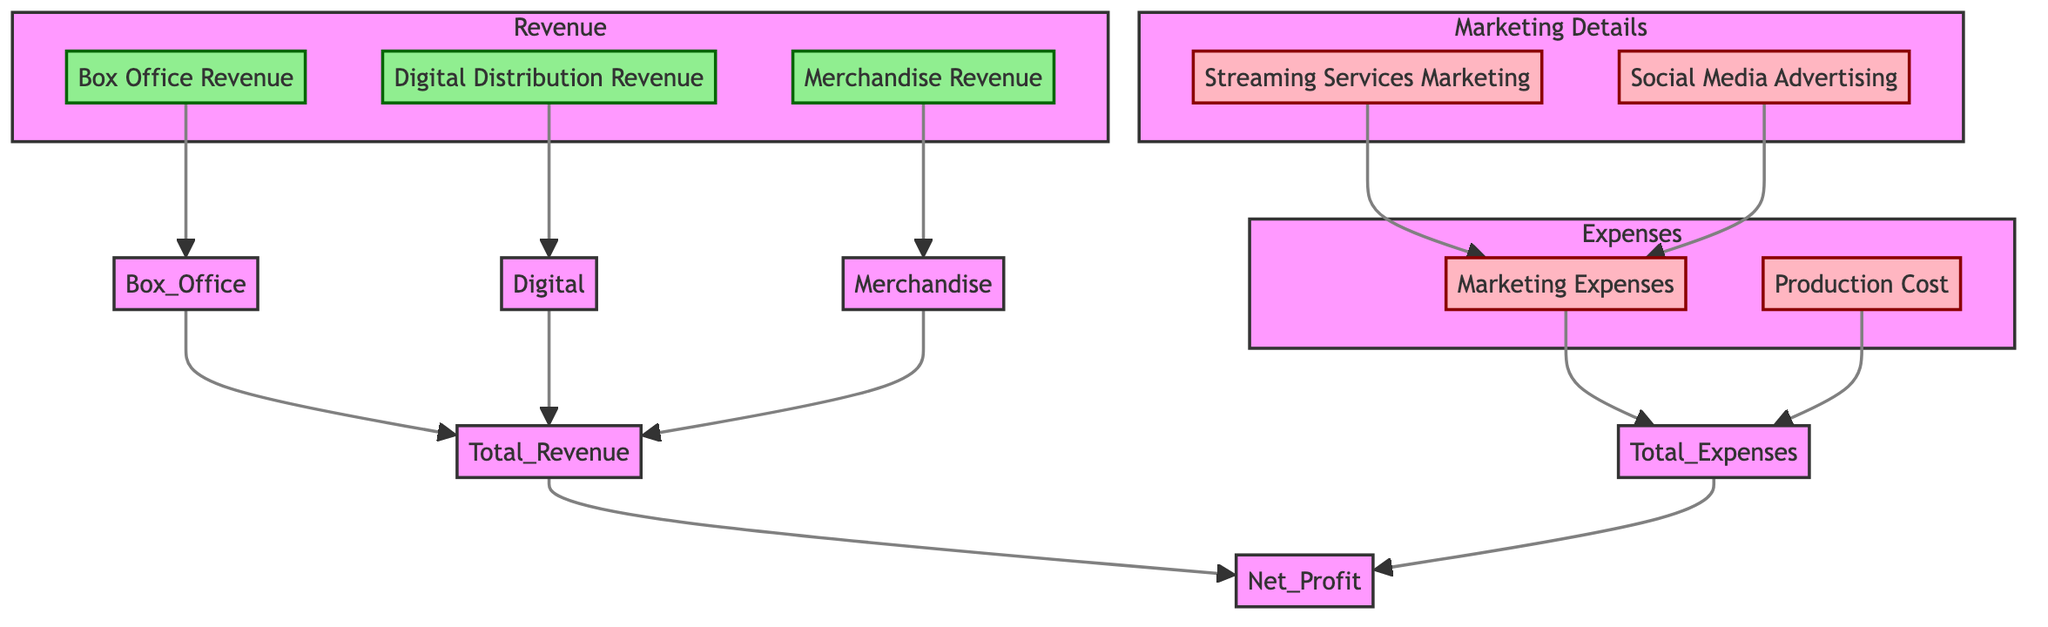What are the three sources of revenue in this diagram? The diagram clearly lists three specific revenue sources: Box Office Revenue, Digital Distribution Revenue, and Merchandise Revenue. These are located within the "Revenue" subgraph.
Answer: Box Office Revenue, Digital Distribution Revenue, Merchandise Revenue How many types of marketing expenses are detailed in this diagram? The diagram specifies two primary types of marketing expenses: Marketing Expenses and Production Cost are the main categories, and within Marketing Expenses, there are two detailed subcategories: Streaming Services Marketing and Social Media Advertising.
Answer: 2 What connects Total Revenue and Net Profit in the diagram? From the diagram, Total Revenue flows directly to Net Profit, indicating that Net Profit is derived from the overall revenue accumulated, showing a direct relationship.
Answer: Total Revenue What are the two components that contribute to Total Expenses? The diagram indicates that Total Expenses are comprised of Marketing Expenses and Production Cost, which are both outlined in the "Expenses" subgraph.
Answer: Marketing Expenses, Production Cost How does Streaming Services Marketing relate to the overall Marketing Expenses? In the diagram, Streaming Services Marketing is a sub-category that feeds into the broader category of Marketing Expenses, meaning that it is part of the overall costs associated with marketing the film.
Answer: It is part of Marketing Expenses What is the primary outcome of subtracting Total Expenses from Total Revenue? The diagram illustrates that the result of subtracting Total Expenses from Total Revenue is displayed as Net Profit, showcasing the primary financial outcome of the film's financial performance analysis.
Answer: Net Profit 